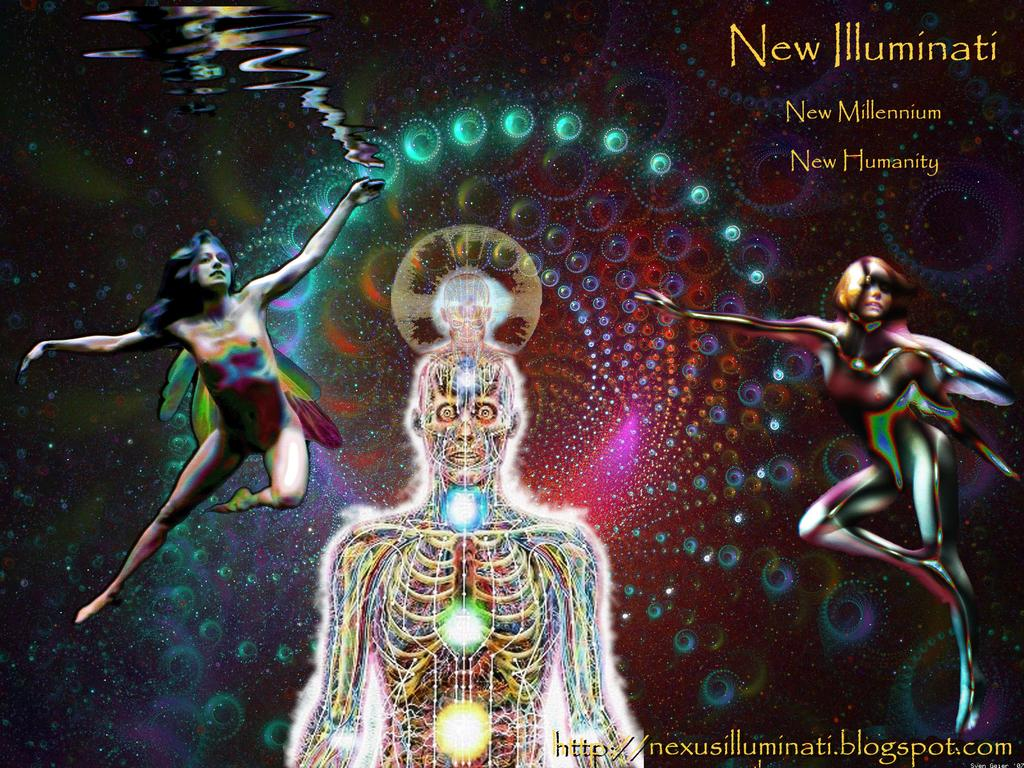<image>
Create a compact narrative representing the image presented. Poster saying "New Illuminati" in yellow on the top right. 